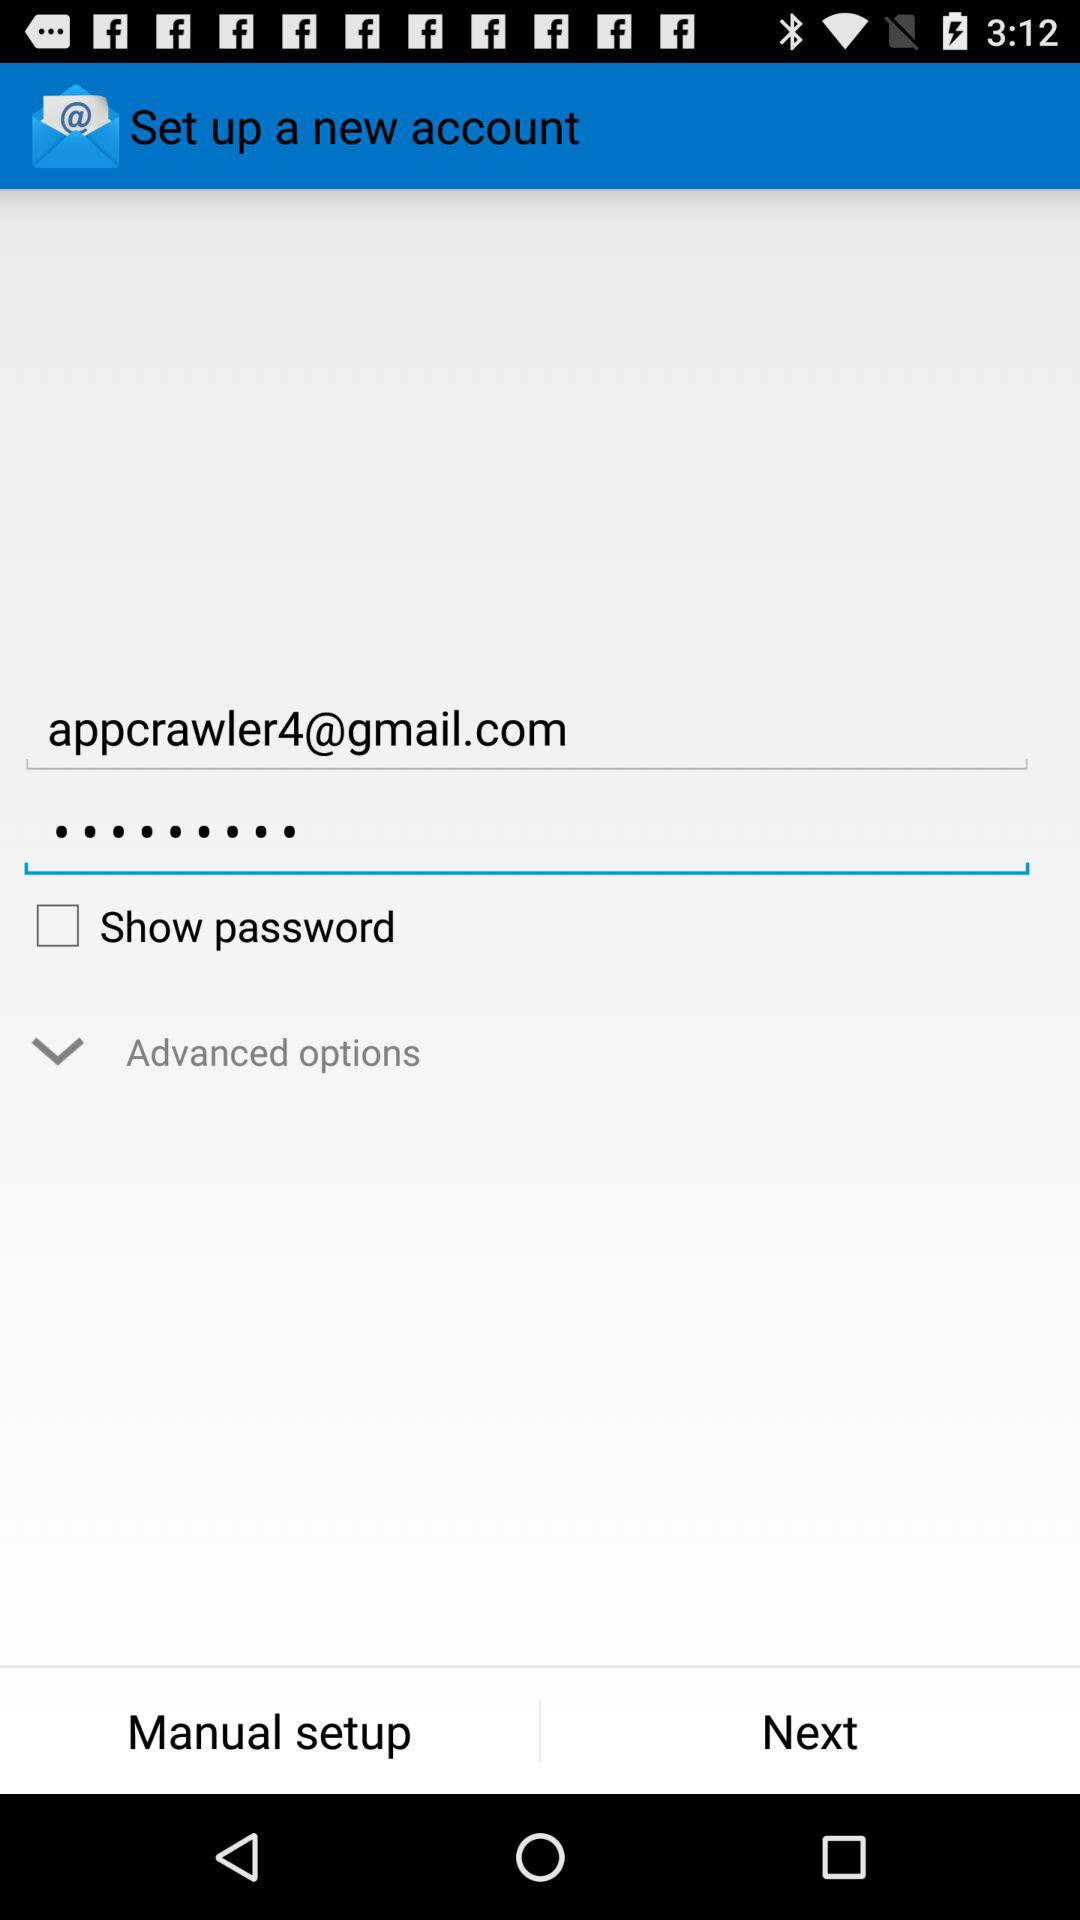What is the email address? The email address is appcrawler4@gmail.com. 